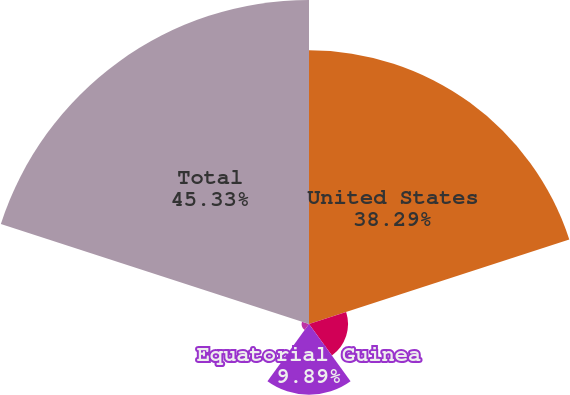<chart> <loc_0><loc_0><loc_500><loc_500><pie_chart><fcel>United States<fcel>North Sea<fcel>Equatorial Guinea<fcel>Other International<fcel>Total<nl><fcel>38.29%<fcel>5.46%<fcel>9.89%<fcel>1.03%<fcel>45.33%<nl></chart> 